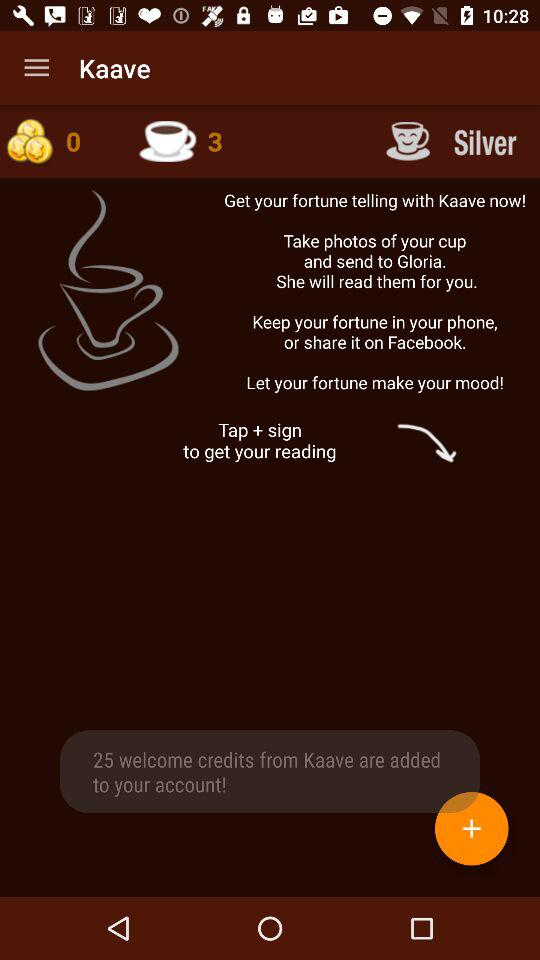How many coins are available? There are 0 available coins. 